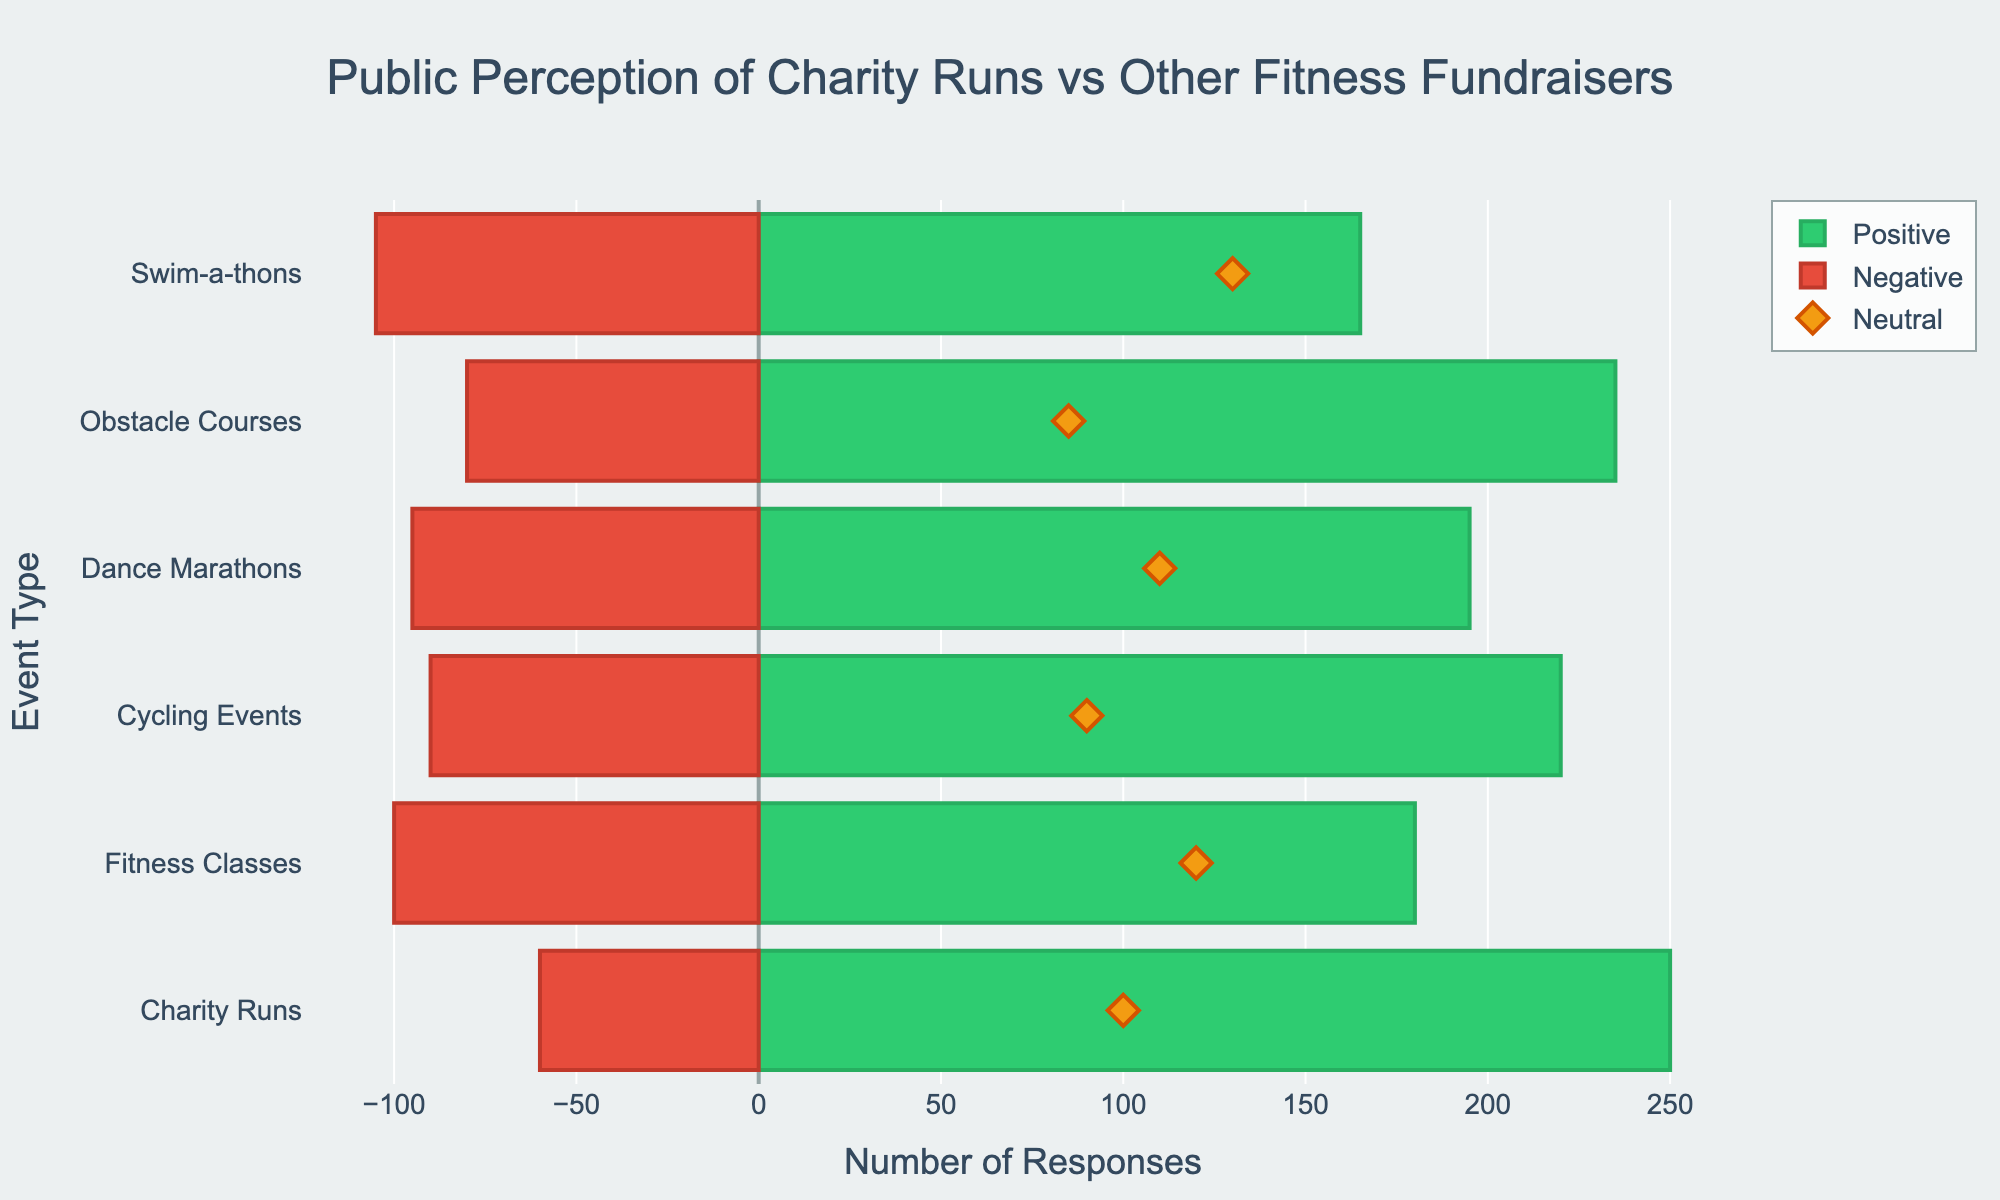what event has the highest number of positive responses? The green bar representing positive responses is longest for the 'Charity Runs' category, indicating it has the highest number of positive responses among all events.
Answer: Charity Runs Which event has the most negative perception? The red bar representing negative responses is longest for the 'Swim-a-thons' category. This indicates that 'Swim-a-thons' have the highest negative perception among all events.
Answer: Swim-a-thons How do Charity Runs compare to Fitness Classes in terms of neutral responses? By comparing the yellow diamond markers on the chart for 'Charity Runs' and 'Fitness Classes', we see that 'Charity Runs' have a neutral response of 100, while 'Fitness Classes' have 120 neutral responses. Thus, 'Fitness Classes' have more neutral responses than 'Charity Runs'.
Answer: Fitness Classes have more neutral responses What is the total number of very positive and very negative responses for Cycling Events? For Cycling Events, there are 40 very positive responses and 20 very negative responses. Adding them together gives a total of 60.
Answer: 60 Which event has the least number of negative responses? The red bar lengths indicate that the 'Charity Runs' category has the shortest red bar, representing the fewest negative responses among all events, totaling 10.
Answer: Charity Runs Is the perception of Obstacle Courses more positive than negative? The green bar representing positive responses for 'Obstacle Courses' is longer than the red bar representing negative responses, indicating a more positive perception.
Answer: Yes, it is more positive What is the difference in total responses between positive and negative for Dance Marathons? Dance Marathons have 35 very positive + 160 positive = 195 positive responses and 70 negative + 25 very negative = 95 negative responses. The difference is 195 - 95 = 100.
Answer: 100 Compare the total number of positive responses between Cycling Events and Fitness Classes. Cycling Events have 40 very positive + 180 positive = 220 positive responses, while Fitness Classes have 30 very positive + 150 positive = 180 positive responses.
Answer: Cycling Events have more positive responses What are the combined neutral responses for Dance Marathons and Swim-a-thons? Dance Marathons have 110 neutral responses and Swim-a-thons have 130 neutral responses. Combined, it totals 110 + 130 = 240.
Answer: 240 Which event has the second highest number of positive responses? 'Obstacle Courses' have the second longest green bar after 'Charity Runs', representing the second highest number of positive responses.
Answer: Obstacle Courses 